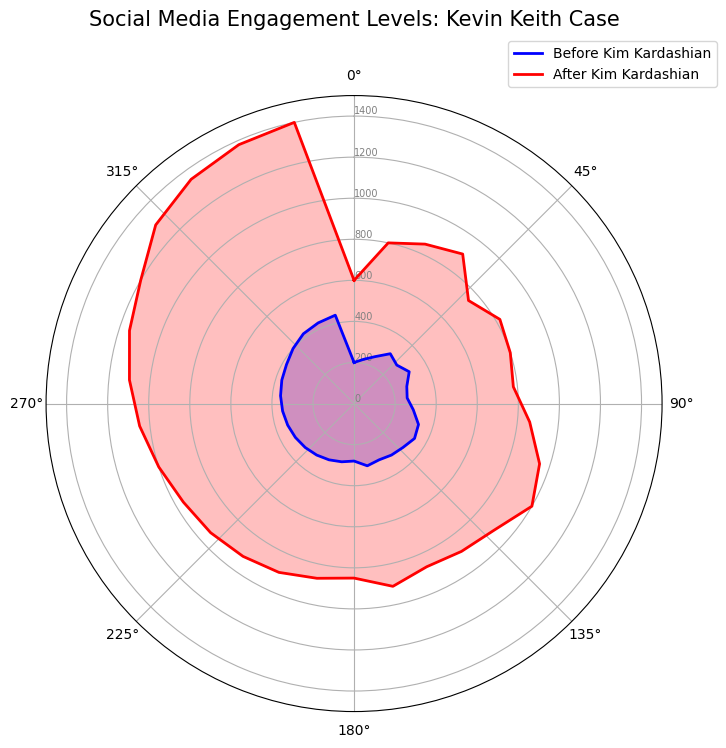What are the main colors representing social media engagement levels before and after Kim Kardashian's involvement? The chart uses two main colors to represent different periods: blue for engagement levels before Kim Kardashian's involvement and red for engagement levels after her involvement. This helps viewers easily distinguish between the two periods.
Answer: Blue and red Which period shows higher social media engagement levels? By observing the heights of the radial lines, it is clear that the red lines (representing engagement levels after Kim Kardashian's involvement) are generally higher than the blue lines (representing engagement levels before her involvement). This indicates that social media engagement levels increased after Kim Kardashian's involvement.
Answer: After Kim Kardashian's involvement What is the approximate difference in engagement levels on June 24th compared to July 1st after Kim Kardashian's involvement? After Kim Kardashian's involvement, the engagement level on June 24th is 1200, and on July 1st, it is 1300. The difference is 1300 - 1200 = 100.
Answer: 100 On which date did the engagement level reach its maximum after Kim Kardashian got involved? The highest point on the red radial lines corresponds to July 22nd, indicating that the engagement level reached a maximum of 1400 on that date.
Answer: July 22nd What is the average engagement level before Kim Kardashian's involvement over the period? To find the average, sum all the engagement levels before her involvement across the dates and divide by the number of data points. (200 + 220 + 250 + 300 + 280 + 310 + 270 + 260 + 290 + 330 + 340 + 320 + 310 + 300 + 310 + 280 + 290 + 300 + 310 + 320 + 330 + 340 + 350 + 360 + 370 + 380 + 400 + 420 + 430 + 440) / 30 = 313
Answer: 313 How much did social media engagement increase on January 7th after Kim Kardashian's involvement compared to before? Engagement level before her involvement on January 7th is 220, and after her involvement is 800. The increase is 800 - 220 = 580.
Answer: 580 Which date showed the smallest difference in social media engagement levels before and after Kim Kardashian got involved? By comparing the differences for each date, the smallest difference is found between the values on February 18th (780 - 260 = 520).
Answer: February 18th How do the engagement levels on March 11th compare before and after Kim Kardashian's involvement? On March 11th, the engagement level before her involvement is 340 and after is 1000. Clearly, the level after her involvement is significantly higher.
Answer: After involvement is higher What can be said about the trend in social media engagement levels before and after Kim Kardashian's involvement? Before her involvement, the engagement levels show a rising trend but more gradually. After her involvement, the engagement levels rise sharply and maintain higher levels, indicating a significant increase in public interest.
Answer: Steeper rise after involvement What was the range of social media engagement levels after Kim Kardashian's involvement by July 22nd? The minimum engagement level after her involvement is on January 1st (600) and the maximum is on July 22nd (1400), so the range is 1400 - 600 = 800.
Answer: 800 